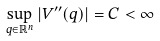Convert formula to latex. <formula><loc_0><loc_0><loc_500><loc_500>\sup _ { q \in \mathbb { R } ^ { n } } \left | V ^ { \prime \prime } ( q ) \right | = C < \infty</formula> 